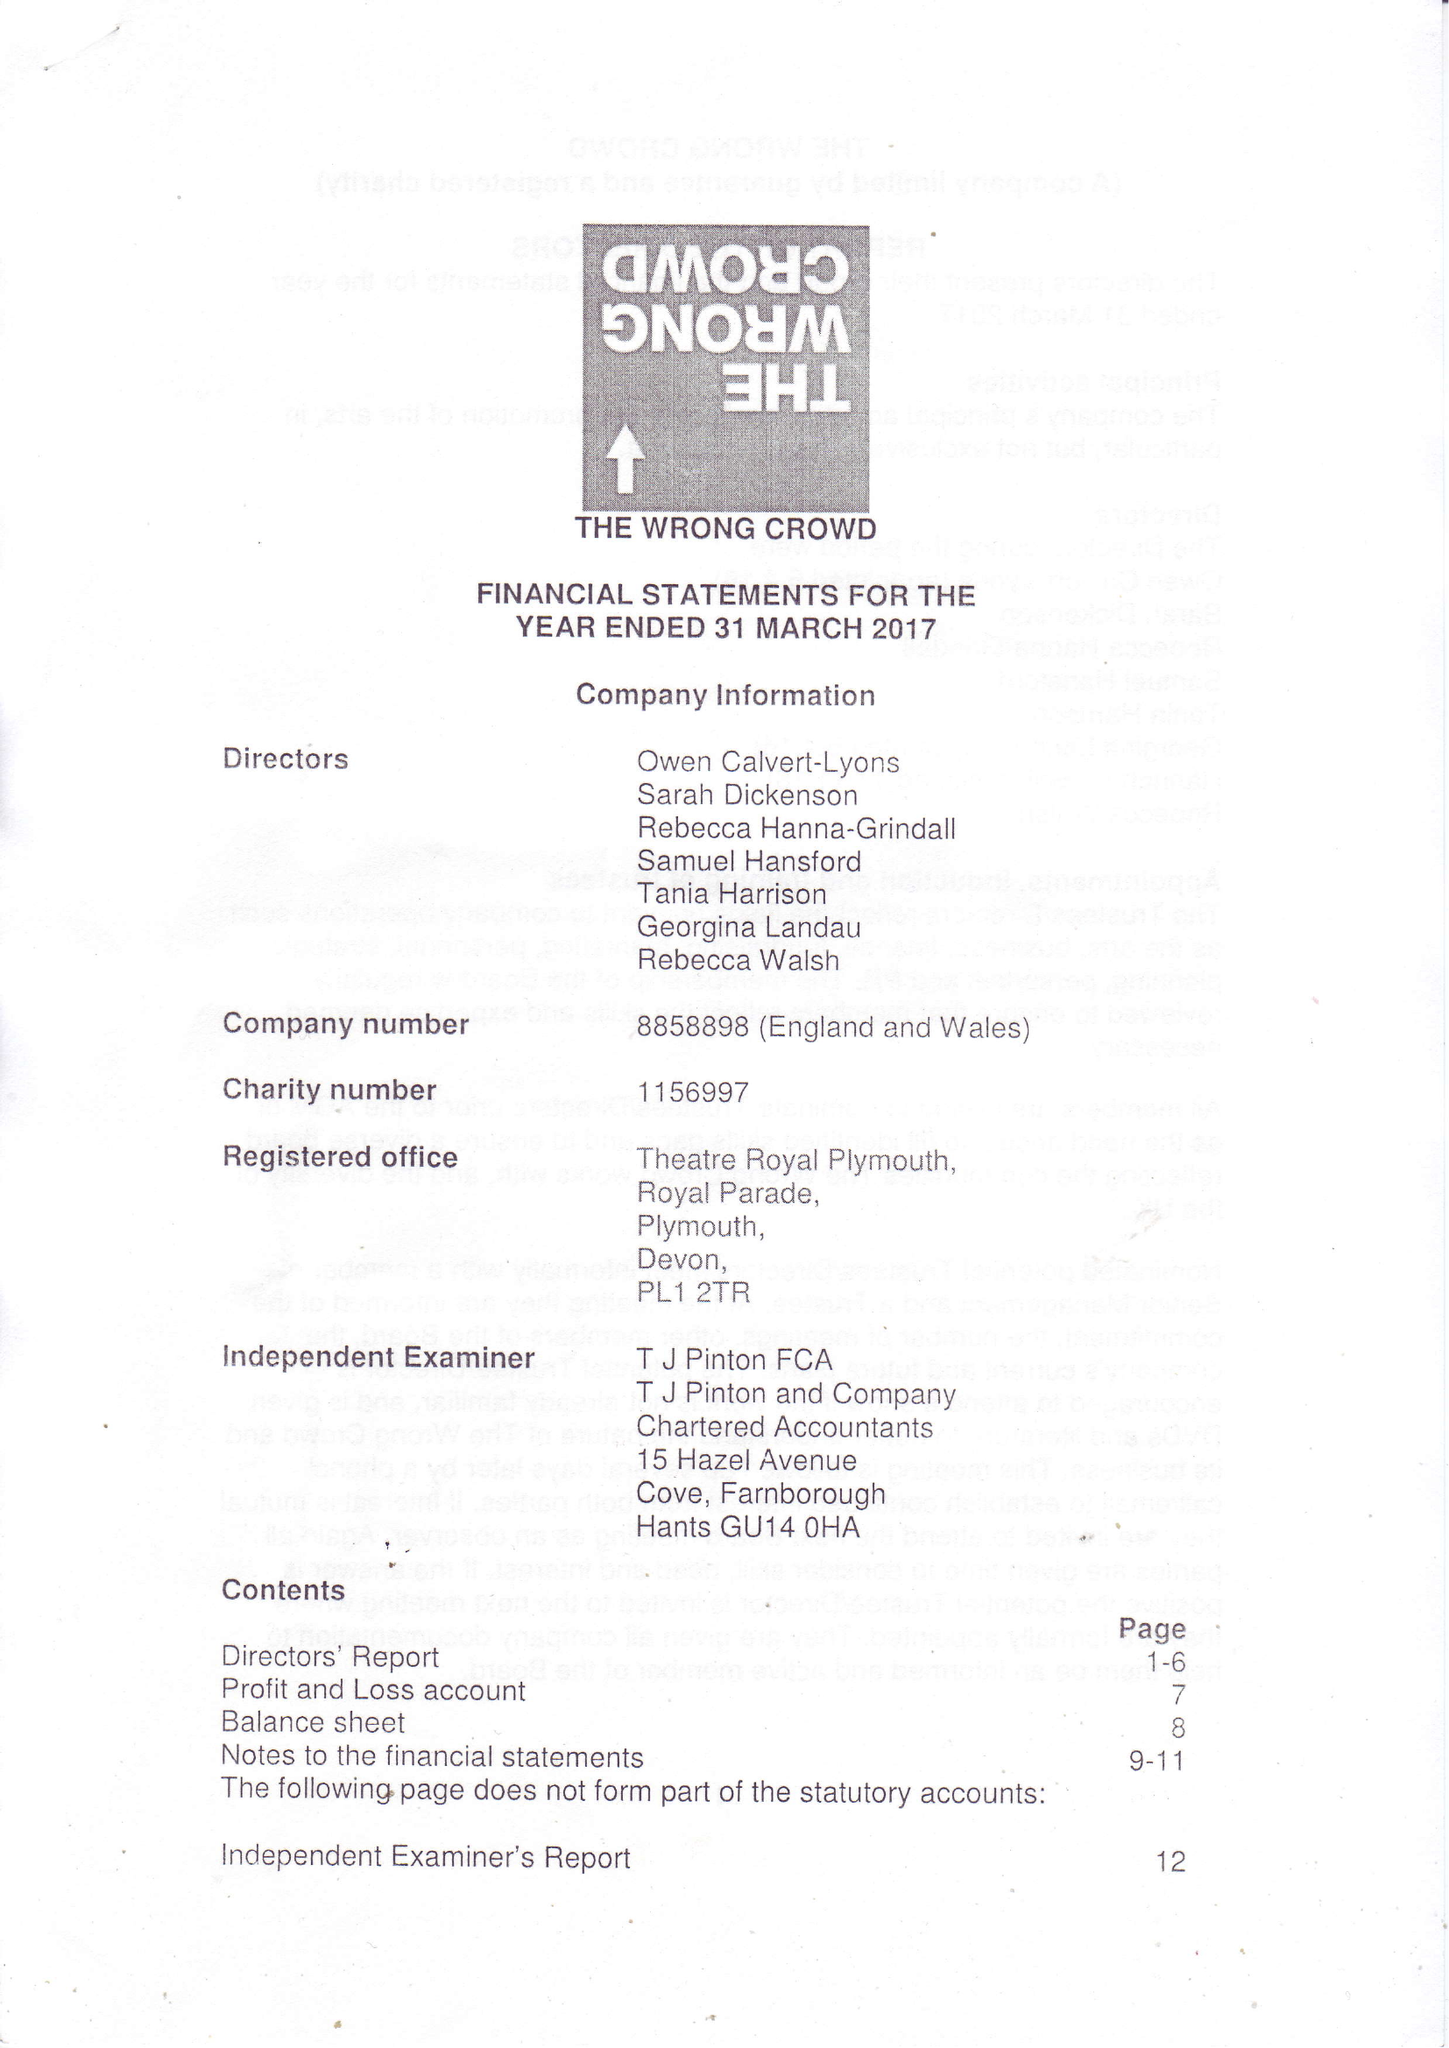What is the value for the income_annually_in_british_pounds?
Answer the question using a single word or phrase. 73730.00 